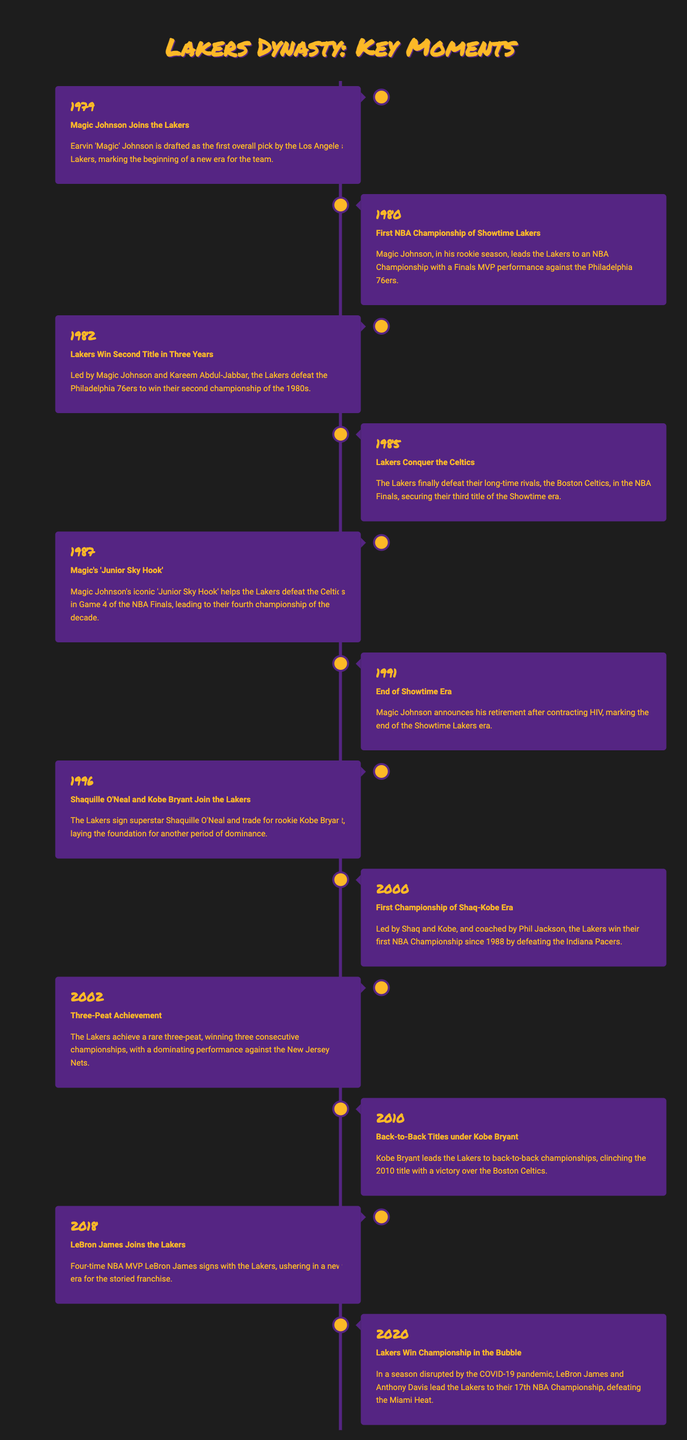What year did Magic Johnson join the Lakers? The document states that Magic Johnson joined the Lakers in 1979.
Answer: 1979 What was the Lakers' first championship year of the Showtime era? The document mentions that the Lakers won their first championship of the Showtime era in 1980.
Answer: 1980 How many championships did the Lakers win during the 1980s? The overall events describe the Lakers winning four championships in the 1980s.
Answer: Four Who were the key players for the Lakers during the 2002 three-peat? The document specifies that the Lakers achieved the three-peat with the help of Shaq and Kobe.
Answer: Shaq and Kobe In which year did LeBron James join the Lakers? The timeline indicates that LeBron James signed with the Lakers in 2018.
Answer: 2018 What event signified the end of the Showtime era? The document states that Magic Johnson's retirement in 1991 marked the end of the Showtime era.
Answer: Magic Johnson's retirement What team did the Lakers defeat to secure the championship in 2020? The document mentions that the Lakers defeated the Miami Heat in the 2020 championship.
Answer: Miami Heat How many consecutive championships did the Lakers win from 2000 to 2002? The text indicates that the Lakers achieved a three-peat, winning three consecutive championships during that time.
Answer: Three What statement is made about the Lakers' rivalry in the 1985 Finals? The document notes that the Lakers finally defeated their long-time rivals, the Boston Celtics, in 1985.
Answer: Defeated the Boston Celtics 